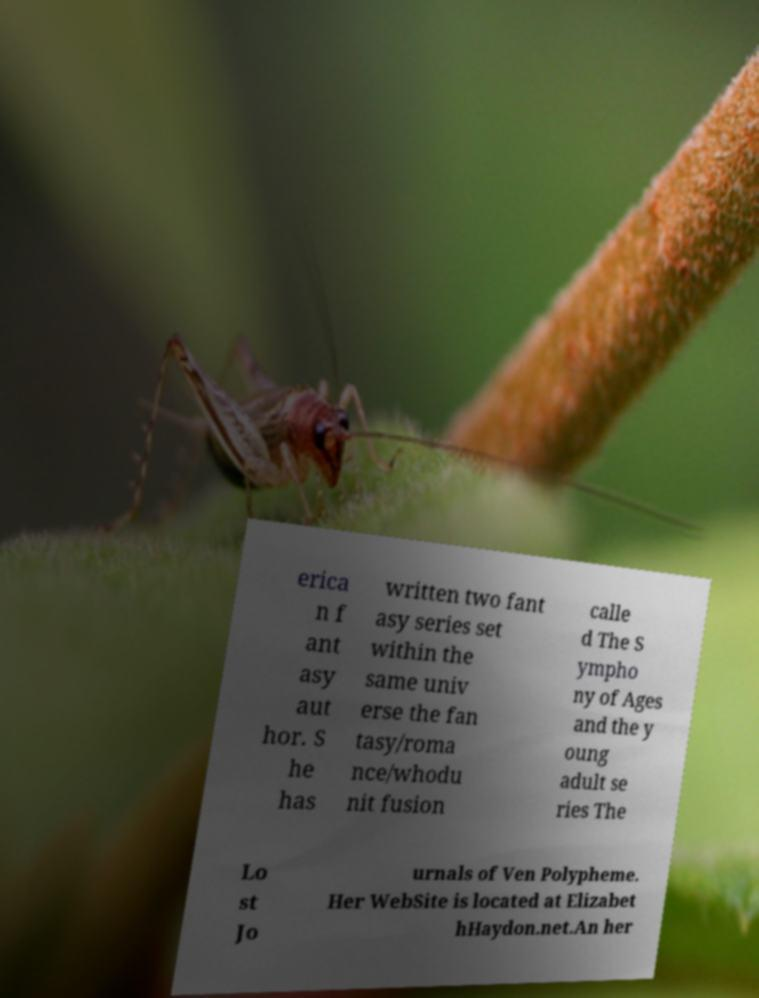I need the written content from this picture converted into text. Can you do that? erica n f ant asy aut hor. S he has written two fant asy series set within the same univ erse the fan tasy/roma nce/whodu nit fusion calle d The S ympho ny of Ages and the y oung adult se ries The Lo st Jo urnals of Ven Polypheme. Her WebSite is located at Elizabet hHaydon.net.An her 